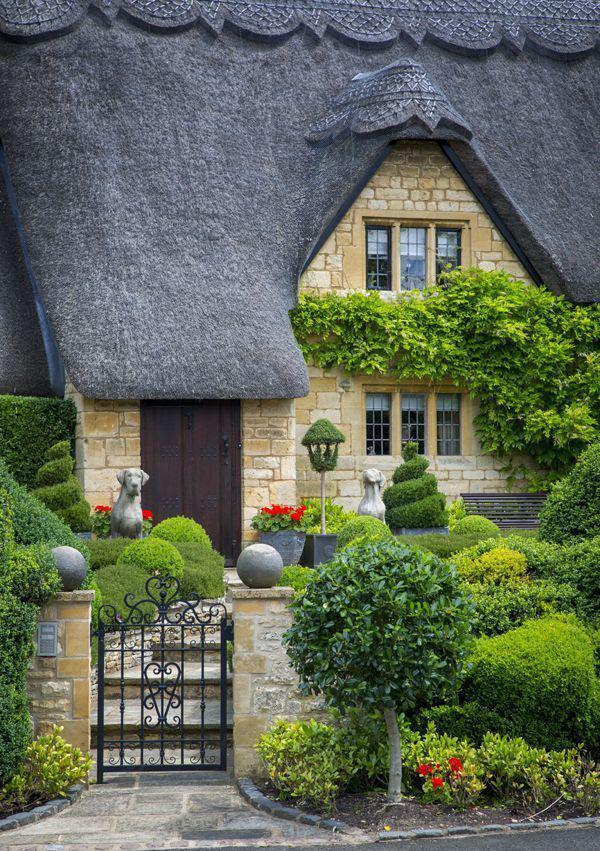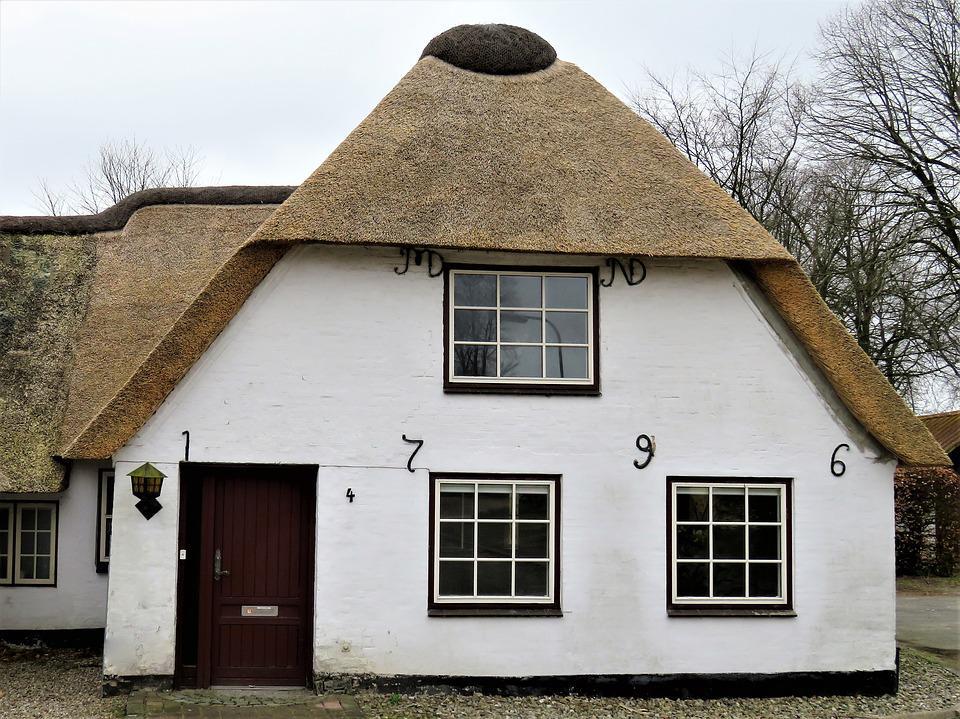The first image is the image on the left, the second image is the image on the right. Given the left and right images, does the statement "An image shows the front of a white house with bold dark lines on it forming geometric patterns, a chimney at at least one end, and a thick gray roof with at least one notched cut-out for windows." hold true? Answer yes or no. No. 